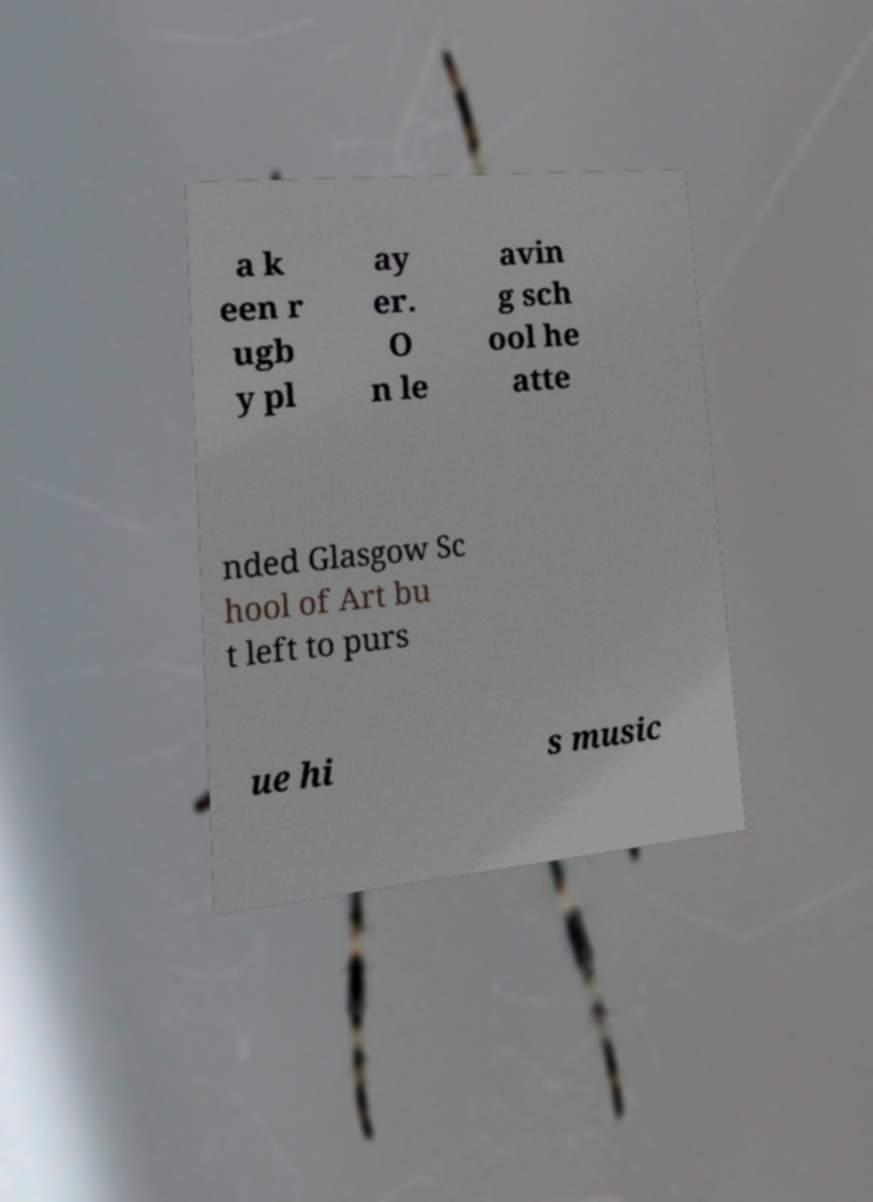Can you read and provide the text displayed in the image?This photo seems to have some interesting text. Can you extract and type it out for me? a k een r ugb y pl ay er. O n le avin g sch ool he atte nded Glasgow Sc hool of Art bu t left to purs ue hi s music 